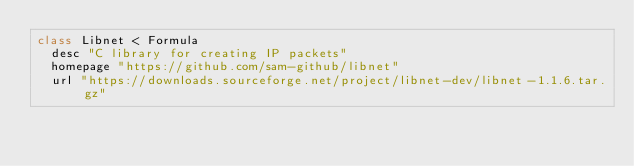Convert code to text. <code><loc_0><loc_0><loc_500><loc_500><_Ruby_>class Libnet < Formula
  desc "C library for creating IP packets"
  homepage "https://github.com/sam-github/libnet"
  url "https://downloads.sourceforge.net/project/libnet-dev/libnet-1.1.6.tar.gz"</code> 